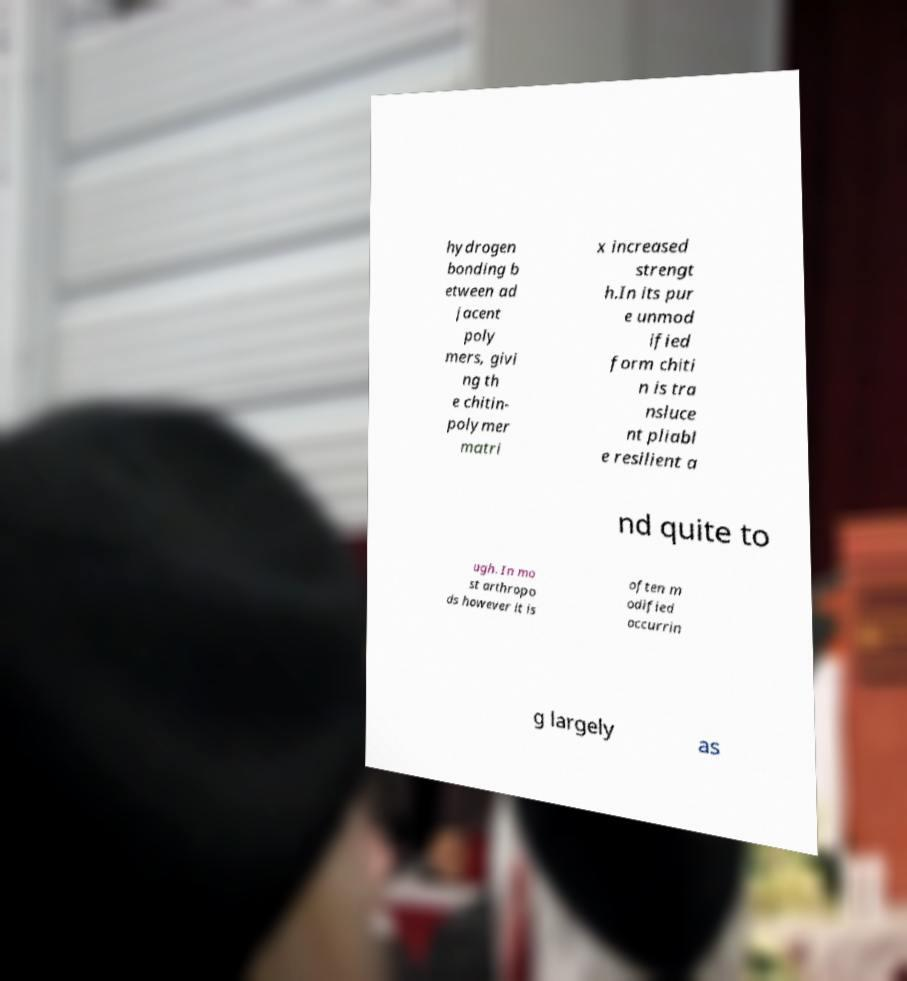Please identify and transcribe the text found in this image. hydrogen bonding b etween ad jacent poly mers, givi ng th e chitin- polymer matri x increased strengt h.In its pur e unmod ified form chiti n is tra nsluce nt pliabl e resilient a nd quite to ugh. In mo st arthropo ds however it is often m odified occurrin g largely as 